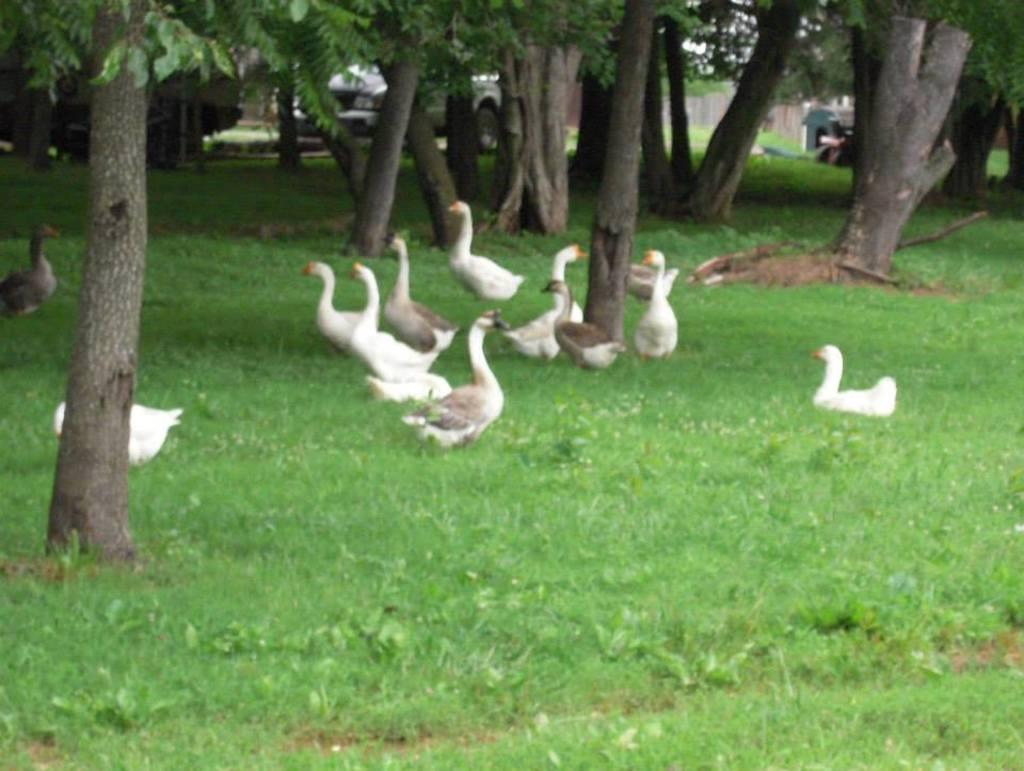What type of animals can be seen on the grassy land in the image? There are ducks on the grassy land in the image. What can be seen in the background of the image? Trees and cars are visible in the background of the image. What type of pickle is being used for writing a fiction story in the image? There is no pickle or writing activity present in the image. 